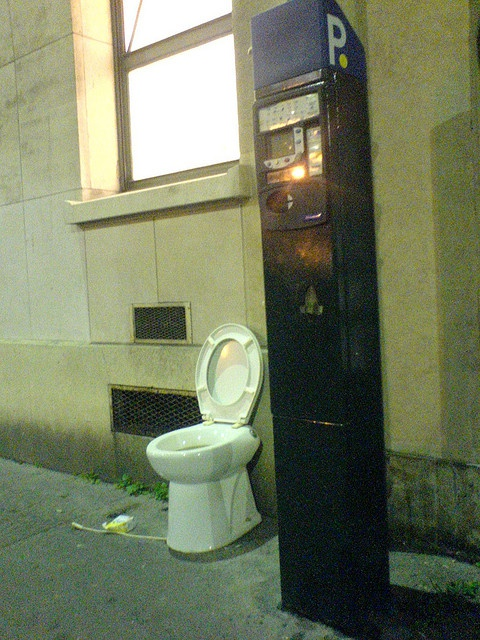Describe the objects in this image and their specific colors. I can see parking meter in tan, black, gray, and darkgreen tones and toilet in tan, darkgray, beige, and gray tones in this image. 